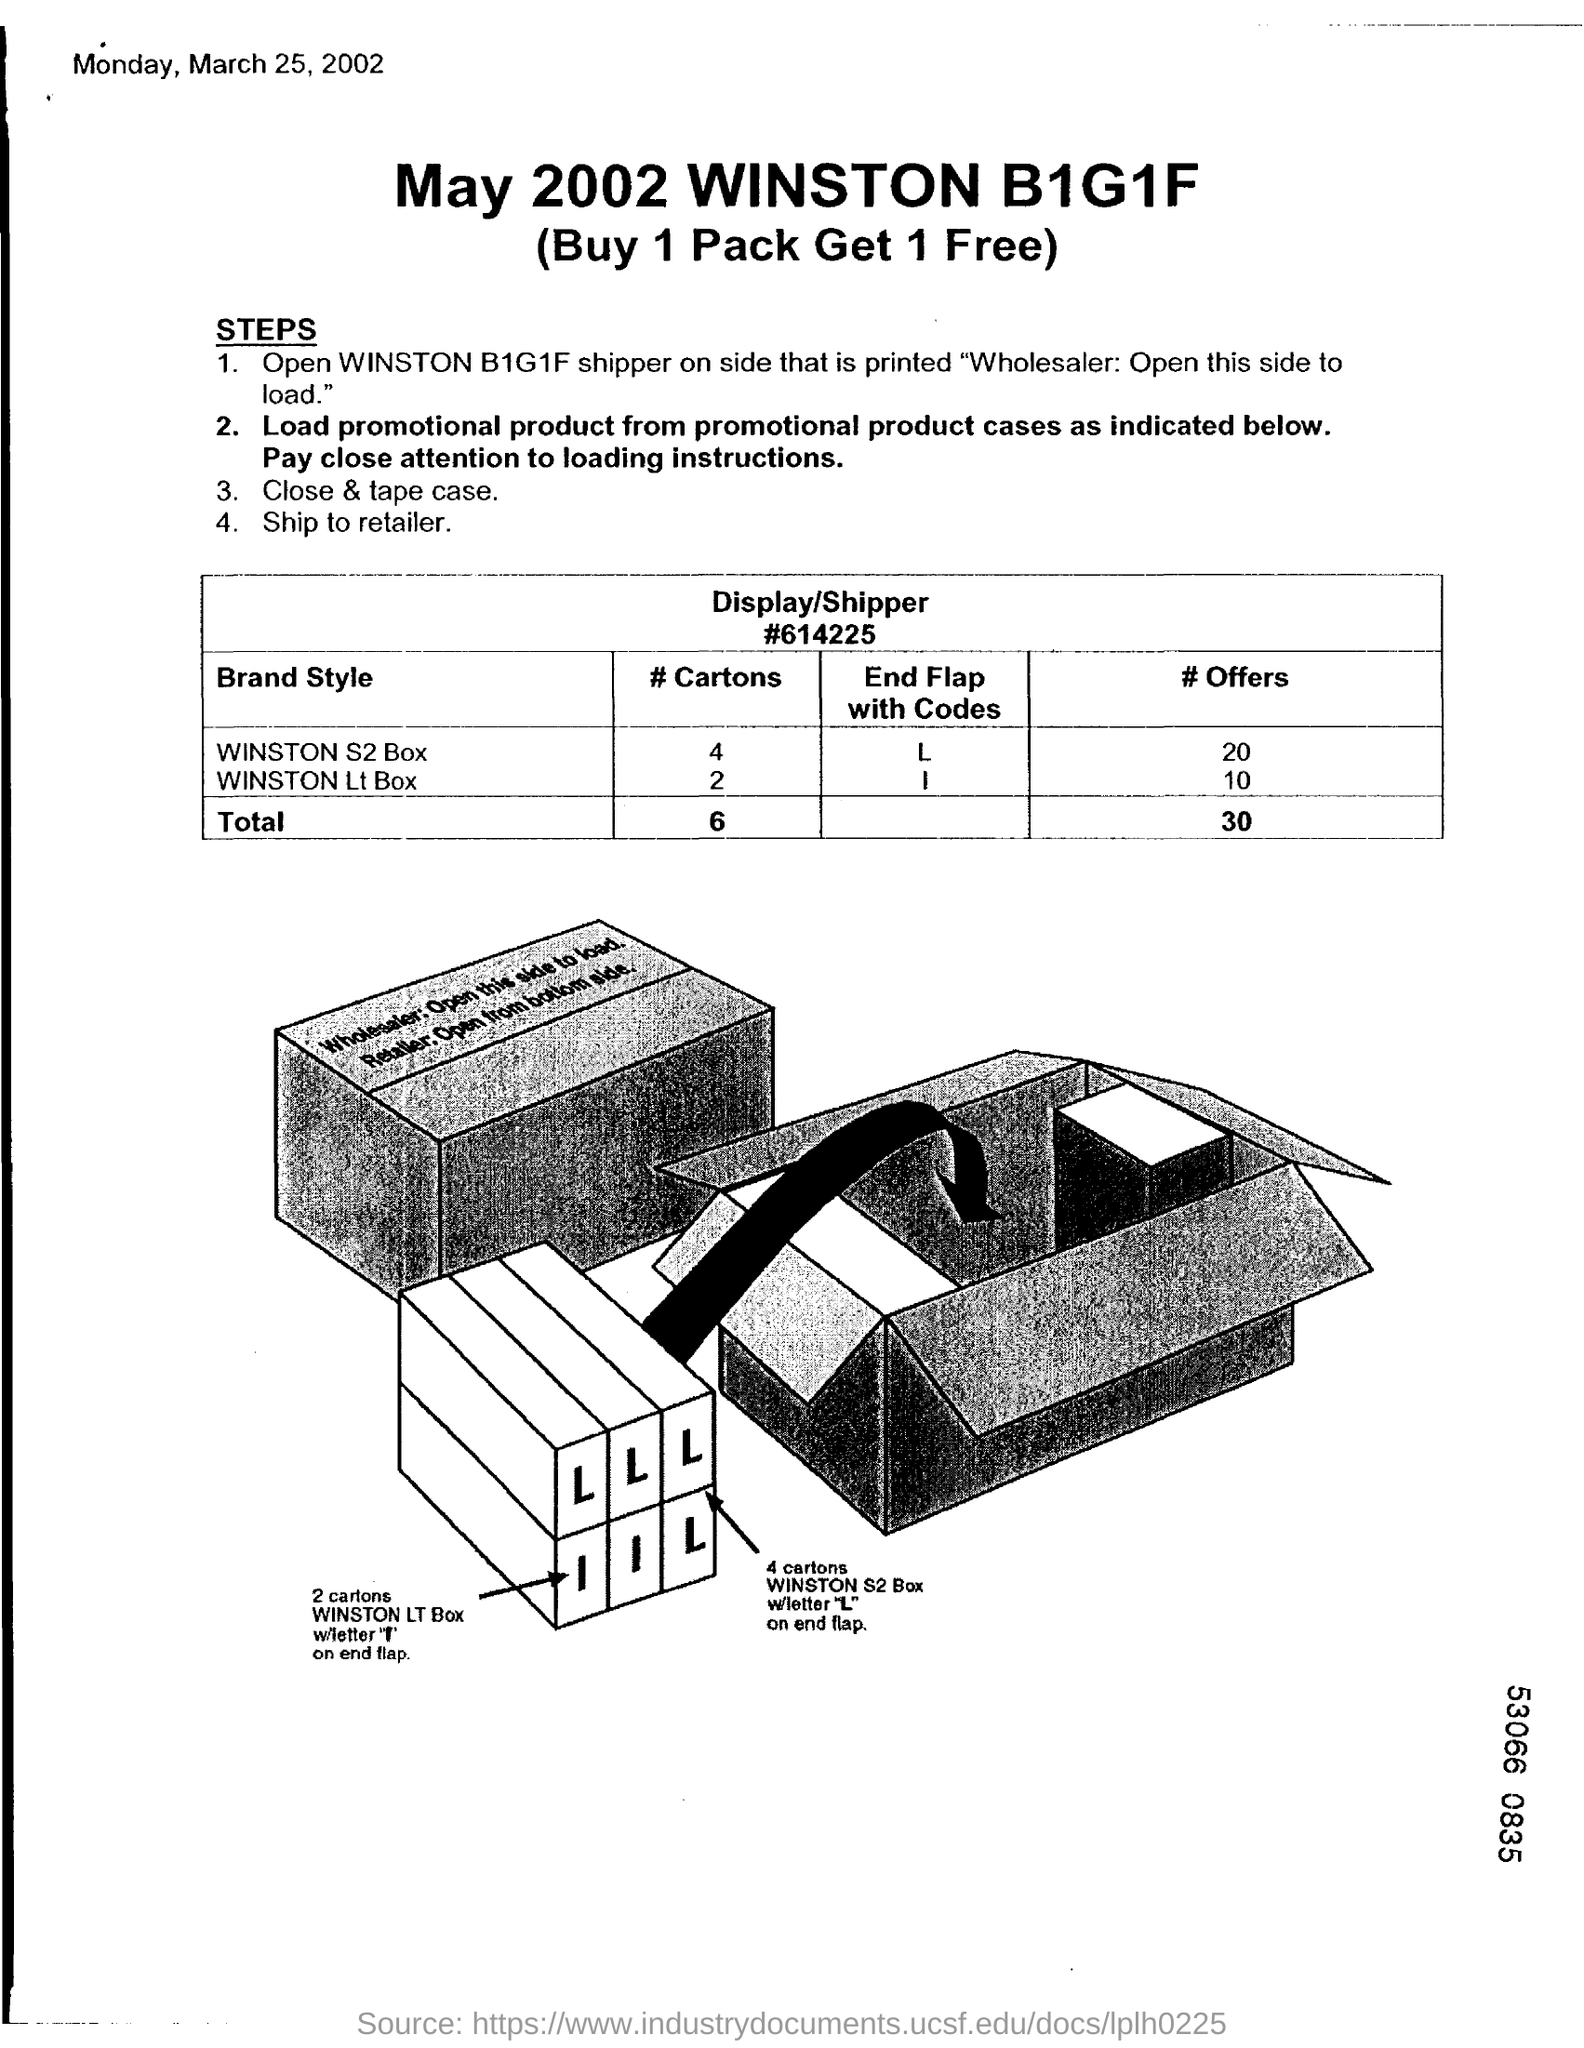What is the date mentioned in the top left corner of the document?
Your response must be concise. Monday, March 25, 2002. What is the title of the document?
Offer a very short reply. May 2002 WINSTON B1G1F. 